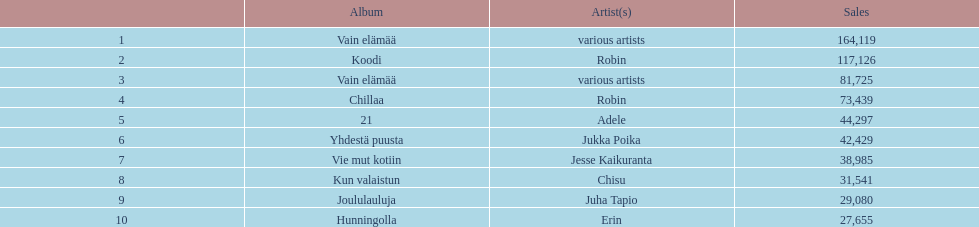Who has sold more records, adele or chisu? Adele. 